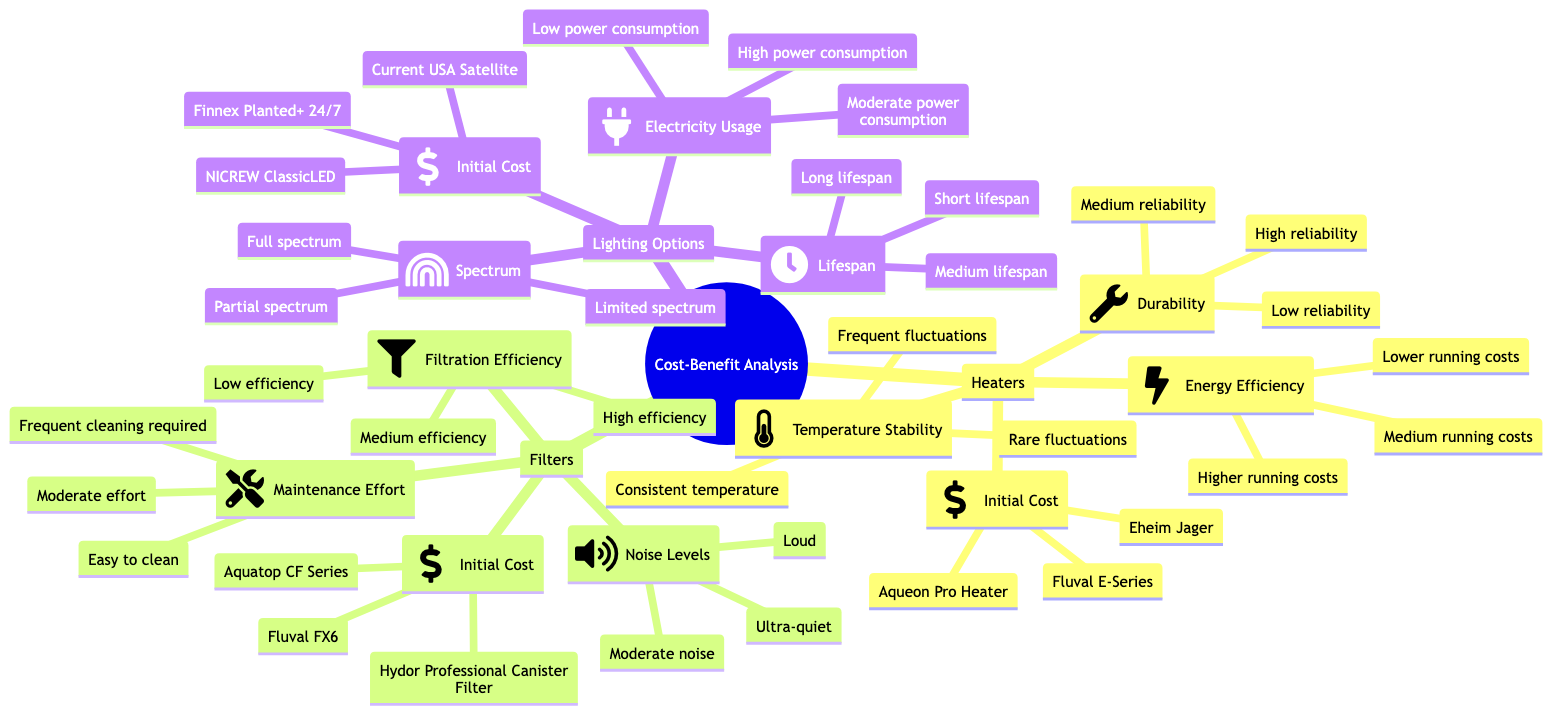What's the initial cost of the Aqueon Pro Heater? The diagram lists "Aqueon Pro Heater" under the "Initial Cost" category for "Heaters." Therefore, the answer is derived directly from the corresponding node.
Answer: Aqueon Pro Heater Which filter has the lowest filtration efficiency? The "Filters" section includes "Filtration Efficiency" with options. By identifying the lowest option in that category, we find "Low efficiency" corresponds to the third filter, which is the "Hydor Professional Canister Filter."
Answer: Low efficiency What is the durability of the Eheim Jager heater? "Eheim Jager" is listed under the "Heaters" section's "Durability." The quality is indicated as "Low reliability," which directly answers the inquiry about its durability.
Answer: Low reliability How many types of lighting options are listed? The diagram details three distinct categories under "Lighting Options." Each category represents a different lighting product. Counting these reveals three types present in the section.
Answer: Three types Which heater has medium running costs? Among the "Energy Efficiency" options under "Heaters," the phrase "Medium running costs" is listed. This matches with one of the heaters, which can be identified as the "Fluval E-Series." Thus, the answer is directly taken from the node itself.
Answer: Fluval E-Series What is the lifespan of the Current USA Satellite lighting option? The "Current USA Satellite" is categorized under "Lifespan" in the "Lighting Options." Its designation is "Short lifespan," which directly answers this question based on the diagram's information.
Answer: Short lifespan Which filter is described as ultra-quiet? The "Noise Levels" category under "Filters" shows "Ultra-quiet" as the first option, linking this attribute directly to the "Fluval FX6" filter. Thus, we conclude the answer based upon its position.
Answer: Fluval FX6 What type of electricity usage is associated with the NICREW ClassicLED? The "NICREW ClassicLED" appears in the "Electricity Usage" section for "Lighting Options." It is associated with the designation "Moderate power consumption," which provides a direct response to the inquiry.
Answer: Moderate power consumption What are the maintenance efforts required for the Aquatop CF Series filter? The diagram indicates that the "Aquatop CF Series" filter is categorized under the "Maintenance Effort," which specifies "Moderate effort" directly connected to that filter type.
Answer: Moderate effort 